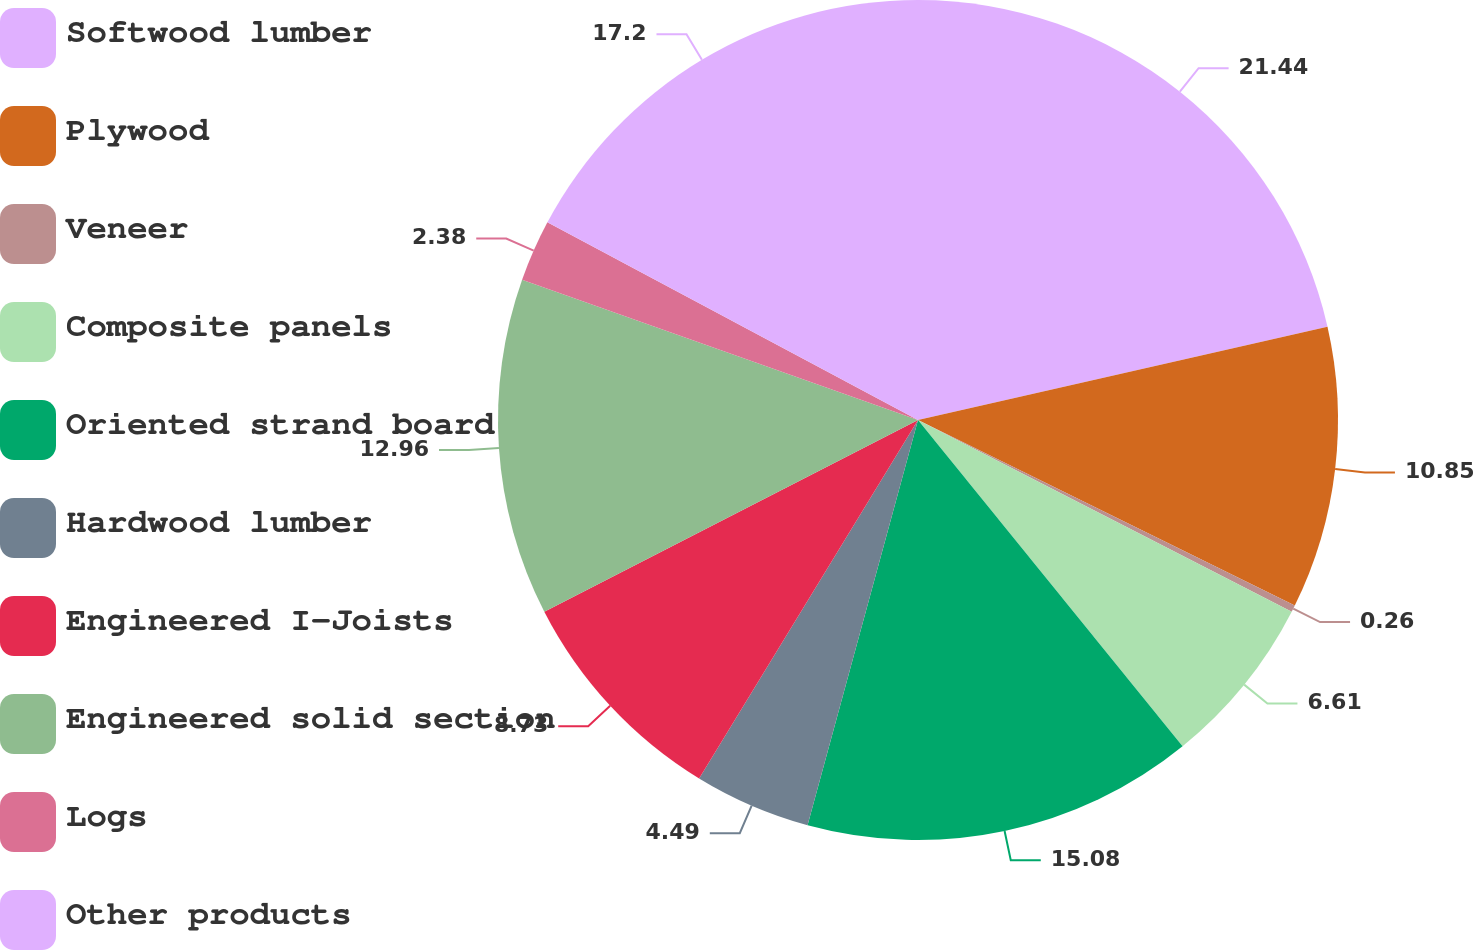<chart> <loc_0><loc_0><loc_500><loc_500><pie_chart><fcel>Softwood lumber<fcel>Plywood<fcel>Veneer<fcel>Composite panels<fcel>Oriented strand board<fcel>Hardwood lumber<fcel>Engineered I-Joists<fcel>Engineered solid section<fcel>Logs<fcel>Other products<nl><fcel>21.43%<fcel>10.85%<fcel>0.26%<fcel>6.61%<fcel>15.08%<fcel>4.49%<fcel>8.73%<fcel>12.96%<fcel>2.38%<fcel>17.2%<nl></chart> 